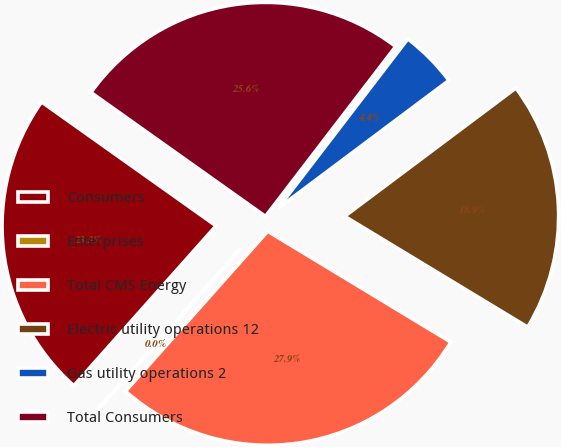Convert chart to OTSL. <chart><loc_0><loc_0><loc_500><loc_500><pie_chart><fcel>Consumers<fcel>Enterprises<fcel>Total CMS Energy<fcel>Electric utility operations 12<fcel>Gas utility operations 2<fcel>Total Consumers<nl><fcel>23.25%<fcel>0.01%<fcel>27.9%<fcel>18.89%<fcel>4.36%<fcel>25.58%<nl></chart> 